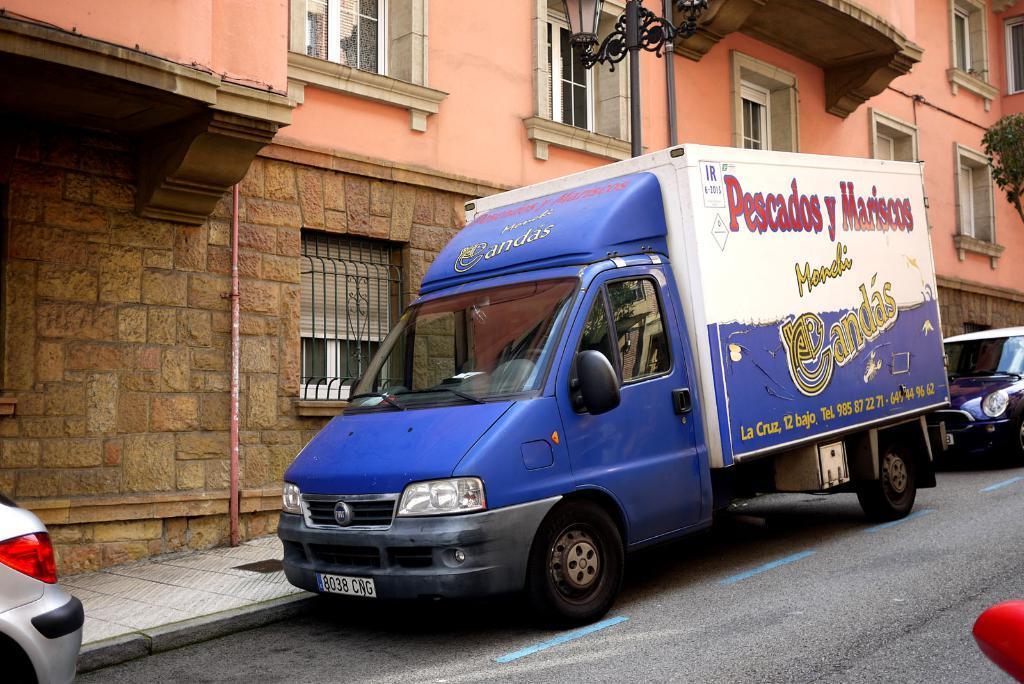How would you summarize this image in a sentence or two? This picture is clicked outside on the road. In the center there is a blue color truck parked on the ground and we can see the text on the truck. On the left corner there is a vehicle seem to be parked on the ground and we can see the lamp attached to the pole and we can see the building, windows of the building. In the background there is a tree and a car parked on the road. 